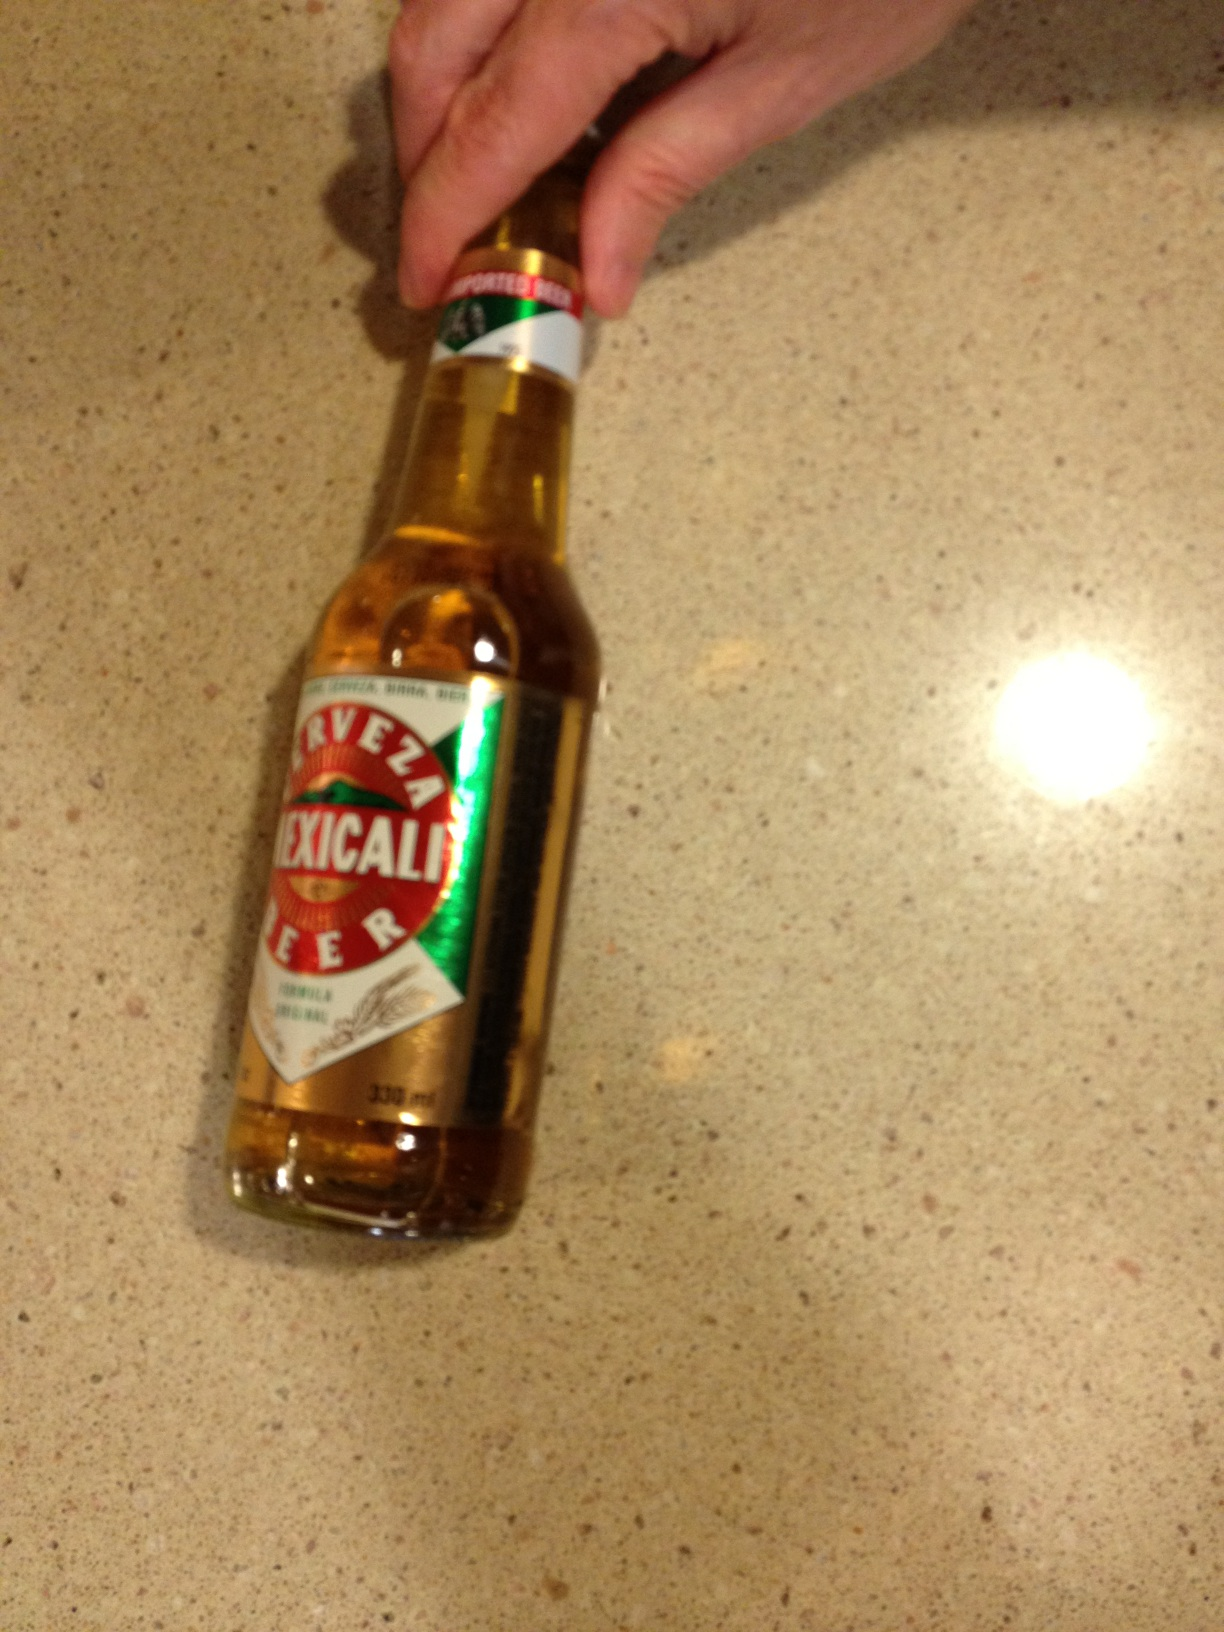I know I can't record very well but could you tell me if you can figure it out what kind of beer this is? Thank you, from Vizwiz Certainly! The beer in the image is a 'Mexicali Beer,' a traditional brew that reflects the robust flavors and culture of Mexico. Enjoy indulging in its unique taste! 